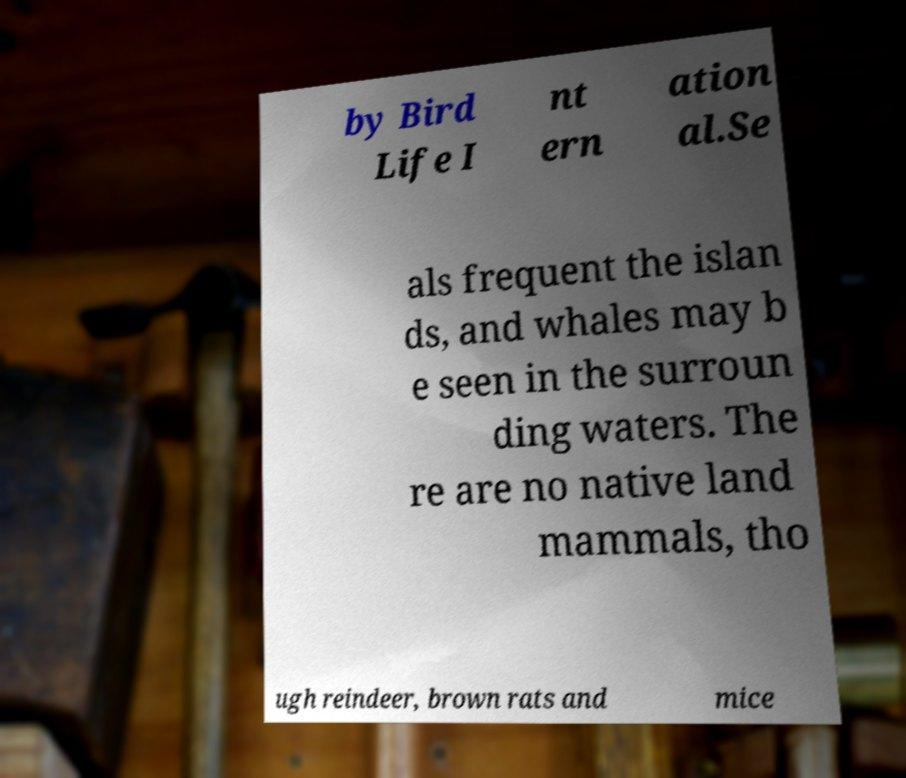Please identify and transcribe the text found in this image. by Bird Life I nt ern ation al.Se als frequent the islan ds, and whales may b e seen in the surroun ding waters. The re are no native land mammals, tho ugh reindeer, brown rats and mice 